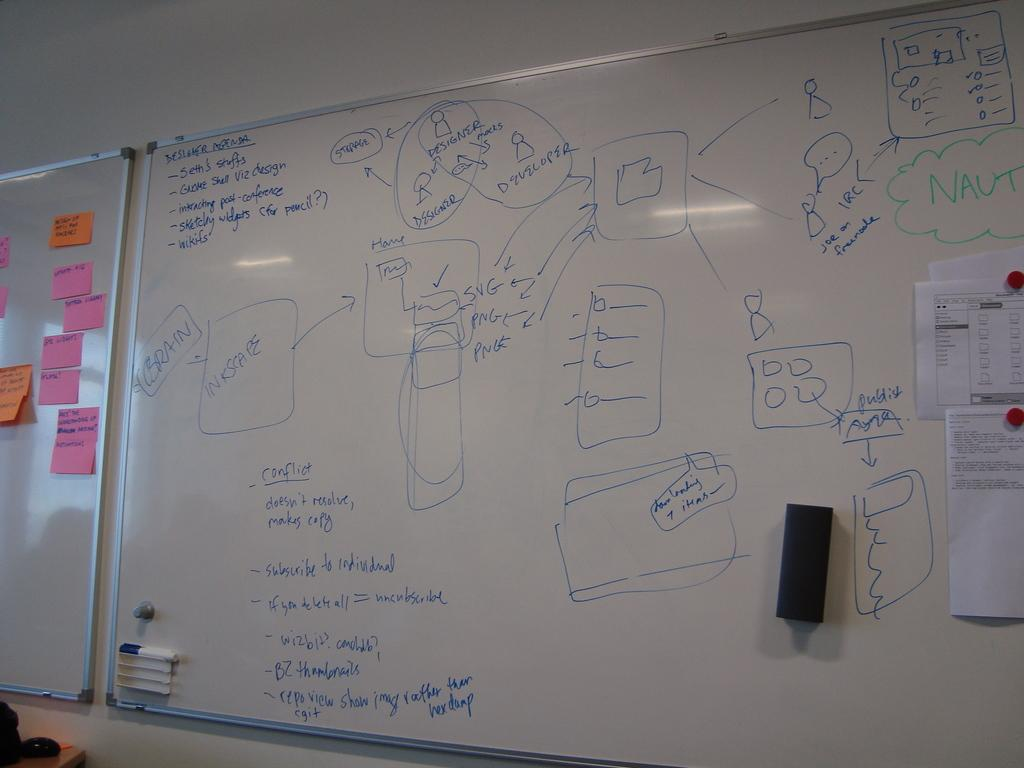Provide a one-sentence caption for the provided image. A list of Designer Agenda is written on a white board. 